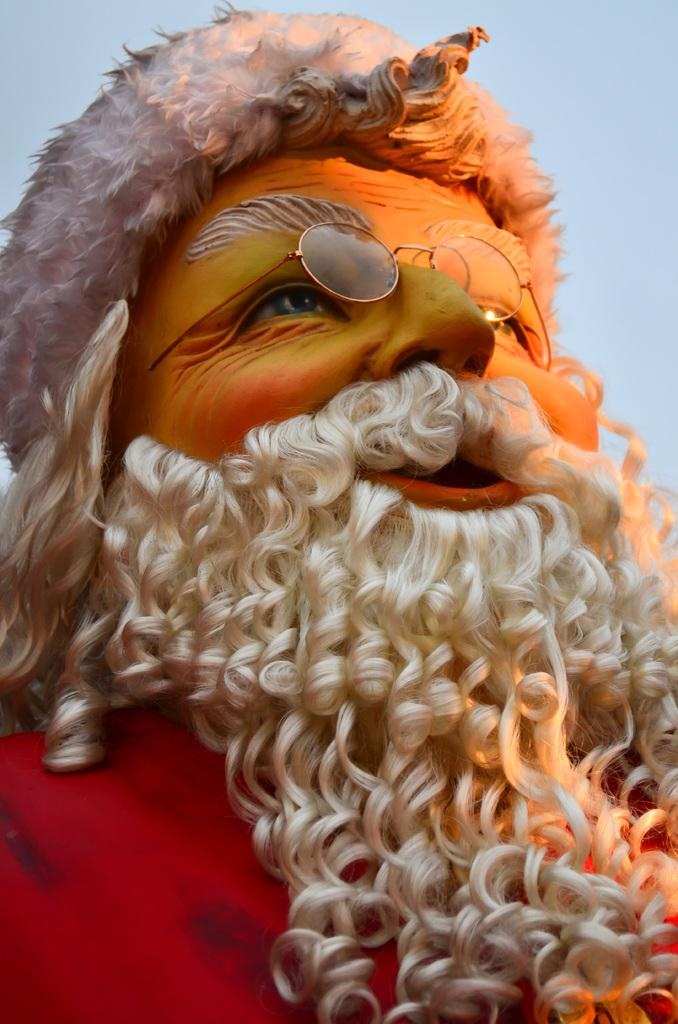What is the main subject in the image? There is a statue in the image. What else can be seen in the image besides the statue? Spectacles are visible in the image. What type of tax is being discussed in the image? There is no mention of tax or any discussion in the image; it features a statue and spectacles. What kind of shoe is depicted on the statue? There is no shoe present on the statue in the image. 